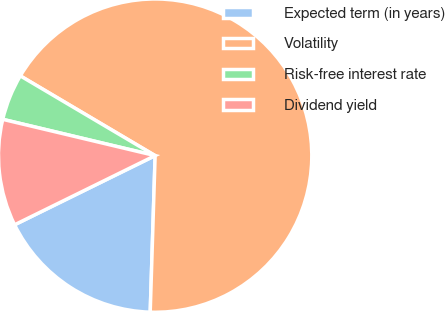Convert chart to OTSL. <chart><loc_0><loc_0><loc_500><loc_500><pie_chart><fcel>Expected term (in years)<fcel>Volatility<fcel>Risk-free interest rate<fcel>Dividend yield<nl><fcel>17.22%<fcel>67.0%<fcel>4.78%<fcel>11.0%<nl></chart> 